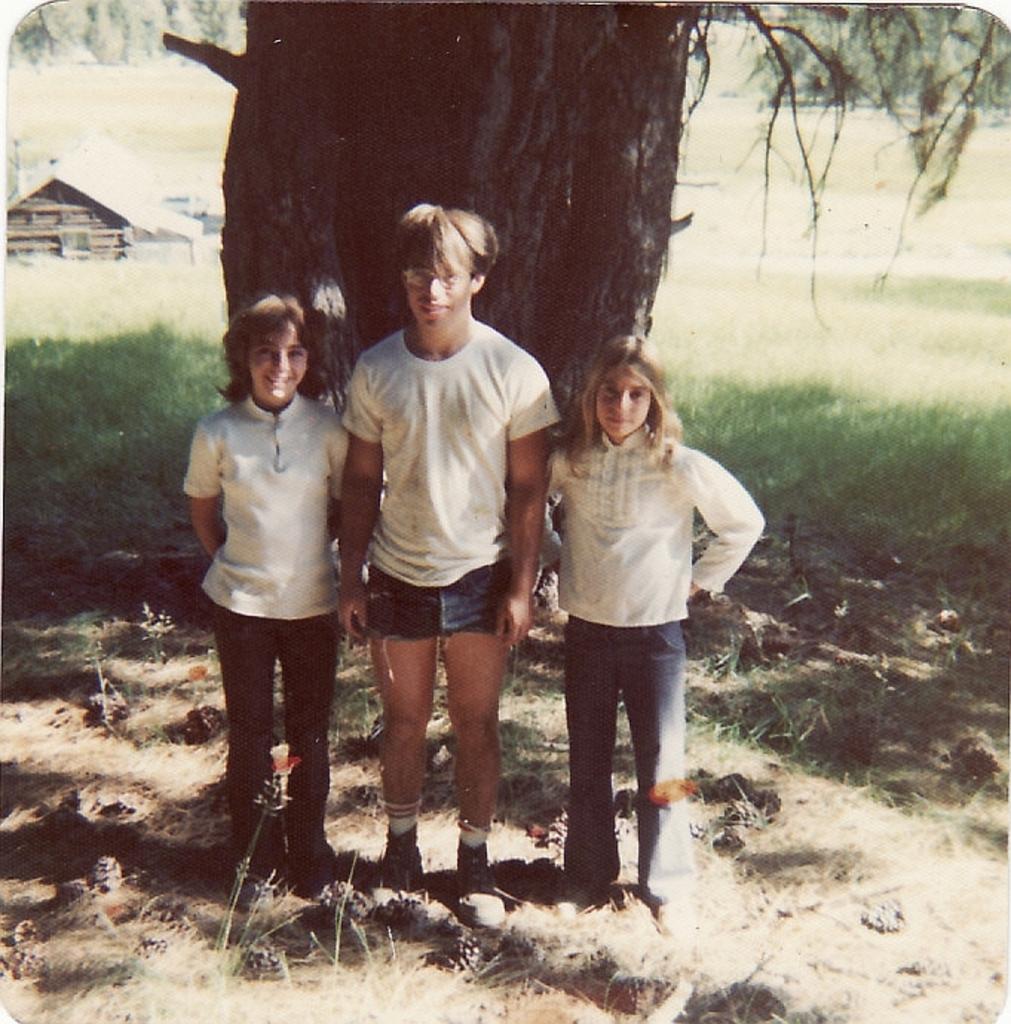Can you describe this image briefly? In this picture I can see there are three persons standing here and the person at the middle is a boy and he is wearing a white t-shirt and a trouser and there are two girls, they are also wearing white shirts and pants. In the backdrop there is a tree and there is grass on the floor and a building and few trees. 